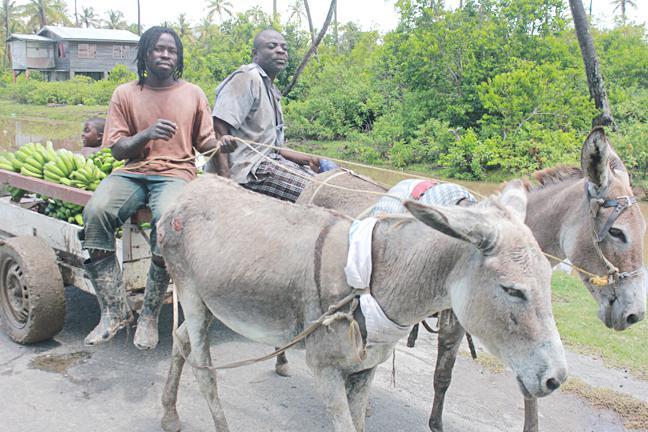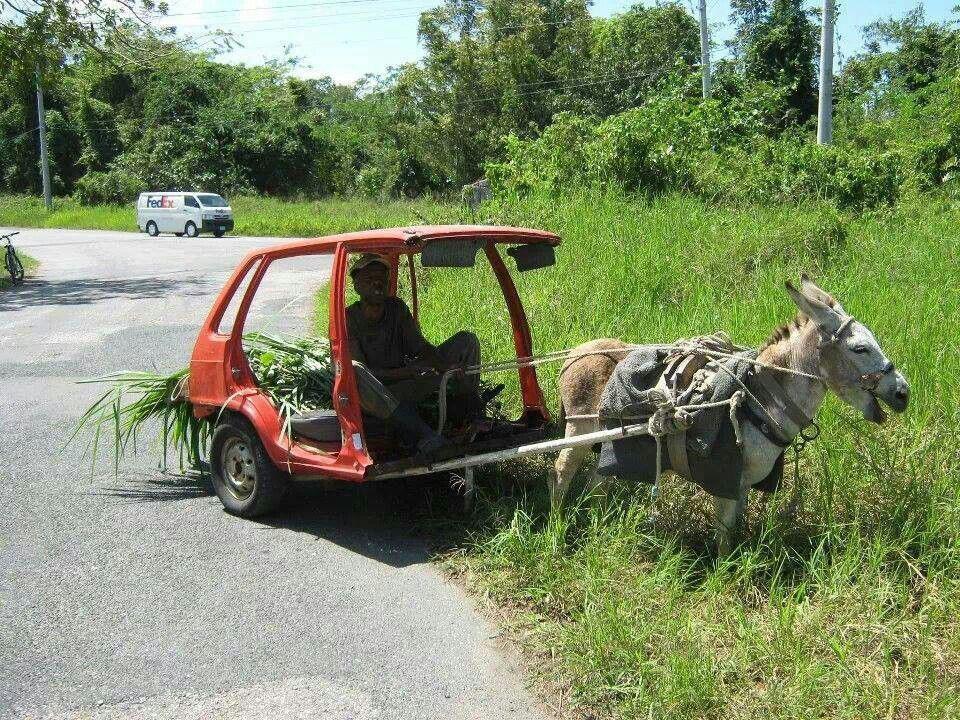The first image is the image on the left, the second image is the image on the right. Analyze the images presented: Is the assertion "The left and right image contains the same number of mules pulling a cart with at least on being a donkey." valid? Answer yes or no. No. The first image is the image on the left, the second image is the image on the right. Examine the images to the left and right. Is the description "The right image shows one animal pulling a wagon with four wheels in a leftward direction." accurate? Answer yes or no. No. 